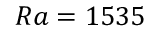<formula> <loc_0><loc_0><loc_500><loc_500>{ R a = 1 5 3 5 }</formula> 